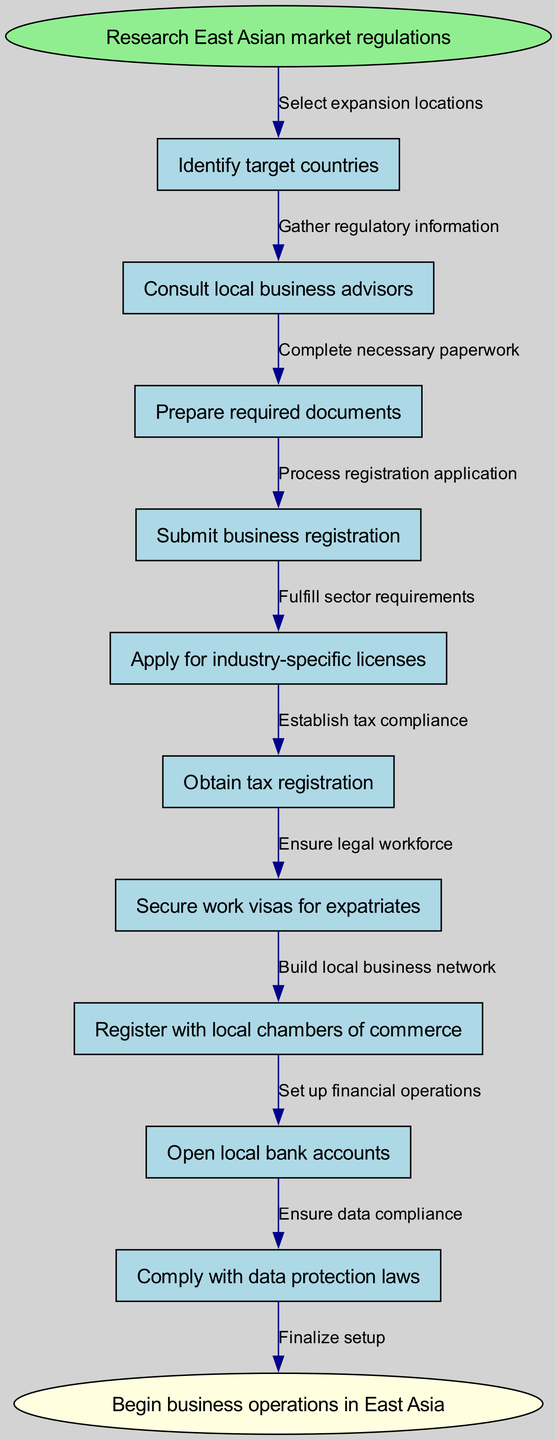What is the first step in the diagram? The first step in the diagram is indicated by the start node, which states "Research East Asian market regulations." This is where the process begins before moving to the next node.
Answer: Research East Asian market regulations How many nodes are in the diagram? Counting all the nodes, including the start and end nodes, there are a total of twelve nodes in the diagram. Each step in the process is represented by a node.
Answer: 12 What is the last step before beginning business operations? The last step before the end node is "Register with local chambers of commerce," which directly connects to the final step of beginning business operations.
Answer: Register with local chambers of commerce Which node comes after "Prepare required documents"? Based on the edges connecting the nodes, "Submit business registration" comes immediately after "Prepare required documents," indicating the next step in the process.
Answer: Submit business registration How many edges connect the nodes? Each step connects to the next with an edge, and since there are twelve nodes, there are a total of eleven edges facilitating the movement from one node to another.
Answer: 11 What is the purpose of "Secure work visas for expatriates"? This step is necessary to ensure that the business can bring in foreign workers legally, fulfilling the legal requirements for employing expatriates in the country of expansion.
Answer: Ensure legal workforce How does "Obtain tax registration" relate to "Comply with data protection laws"? "Obtain tax registration" is part of establishing tax compliance, while "Comply with data protection laws" is about fulfilling legal obligations; both are crucial for ensuring the business operates within legal frameworks but serve different regulatory aspects.
Answer: Establish tax compliance and ensure legal compliance Which step is required for financial operations? "Open local bank accounts" is the step necessary to set up financial operations, as it allows the business to conduct banking activities within the country.
Answer: Open local bank accounts What connects "Apply for industry-specific licenses" to the next step? The connection from "Apply for industry-specific licenses" to "Obtain tax registration" is established through an edge that signifies the completion of the license application, leading to the next regulatory requirement.
Answer: Fulfill sector requirements 